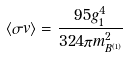Convert formula to latex. <formula><loc_0><loc_0><loc_500><loc_500>\langle \sigma v \rangle = \frac { 9 5 g _ { 1 } ^ { 4 } } { 3 2 4 \pi m _ { B ^ { ( 1 ) } } ^ { 2 } }</formula> 